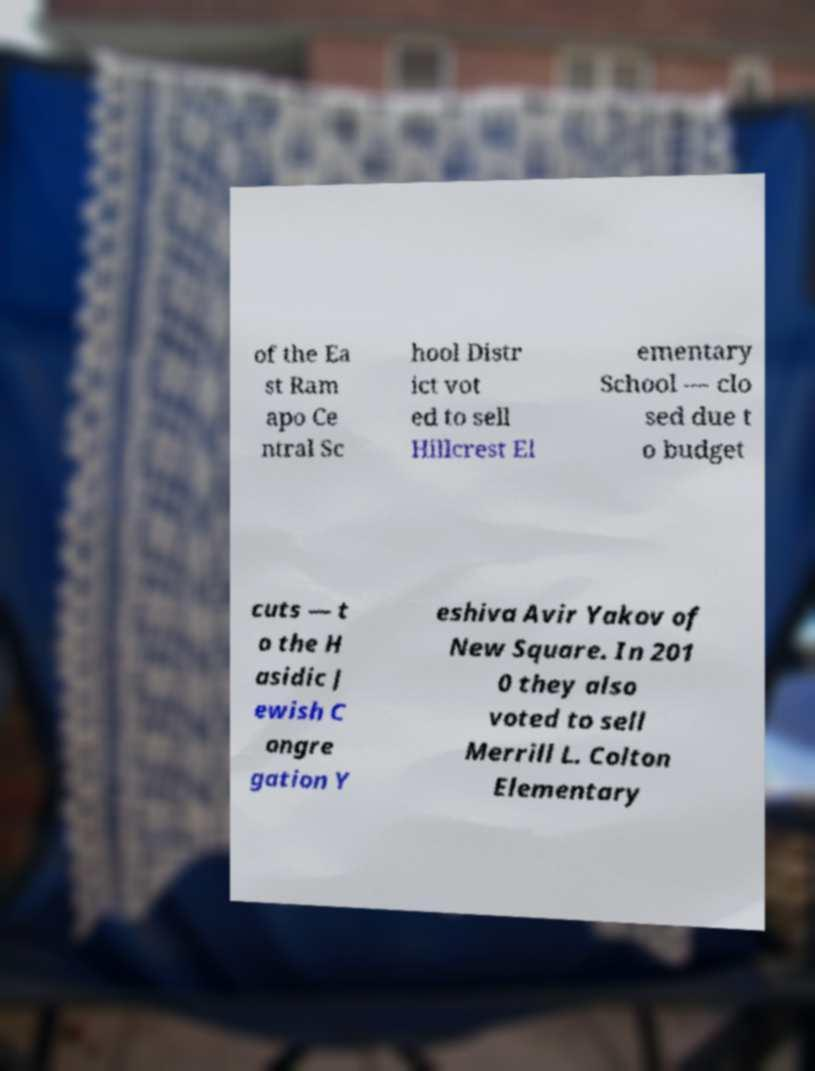Can you accurately transcribe the text from the provided image for me? of the Ea st Ram apo Ce ntral Sc hool Distr ict vot ed to sell Hillcrest El ementary School — clo sed due t o budget cuts — t o the H asidic J ewish C ongre gation Y eshiva Avir Yakov of New Square. In 201 0 they also voted to sell Merrill L. Colton Elementary 